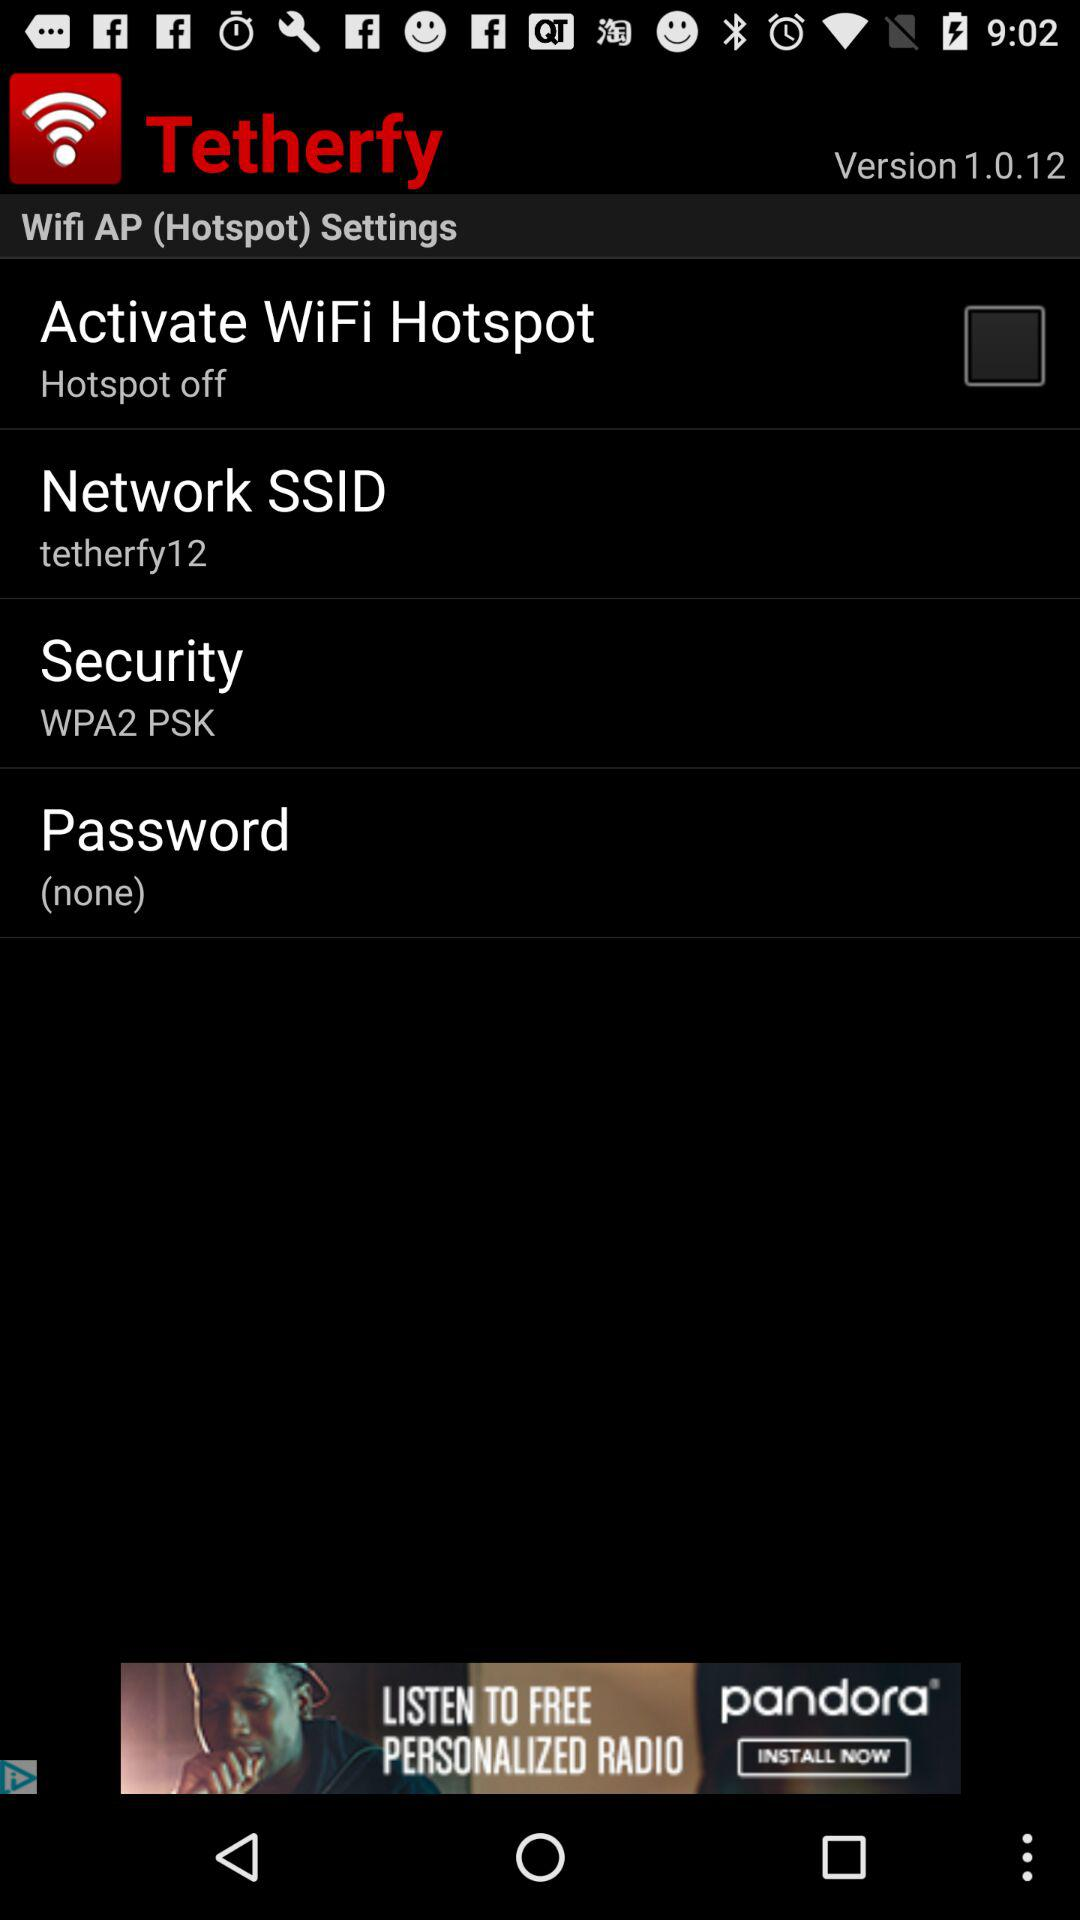Which version is used? The used version is 1.0.12. 